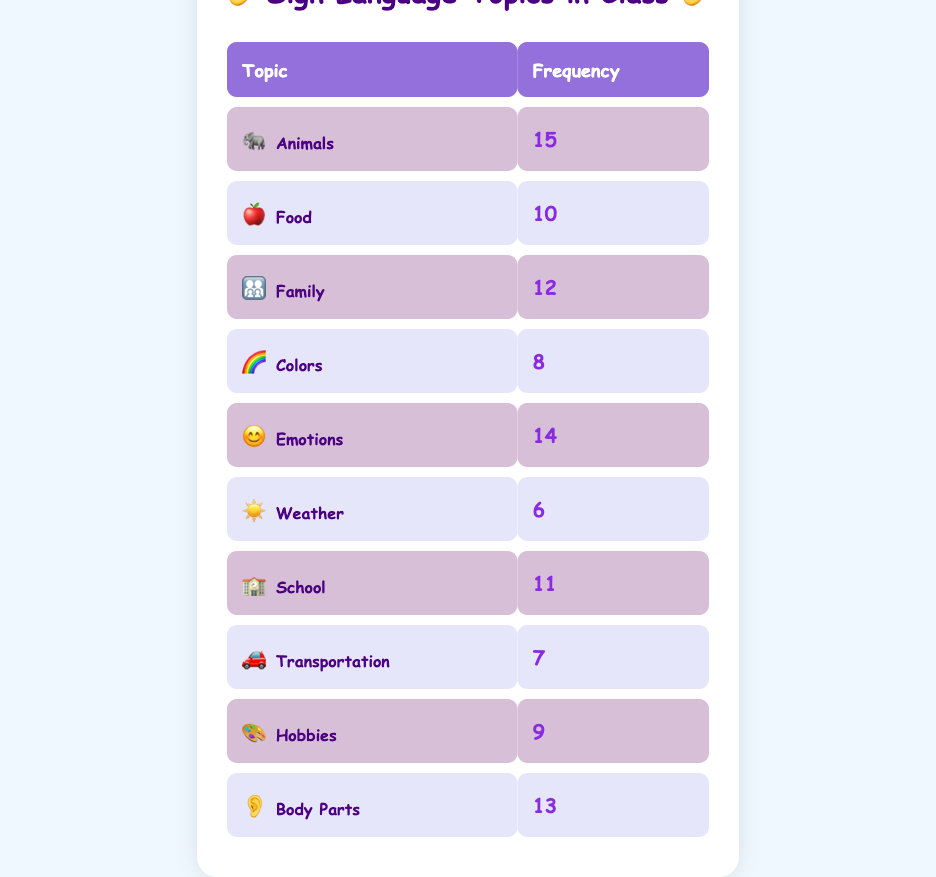What is the most frequently discussed sign language topic? The most frequently discussed topic in the table is "Animals," which has the highest frequency of 15.
Answer: Animals What is the frequency of the "Weather" topic? The table lists "Weather" with a frequency of 6.
Answer: 6 Which topic has a frequency higher than 12? The topics with frequencies higher than 12 are "Animals" (15), "Emotions" (14), and "Body Parts" (13).
Answer: Animals, Emotions, Body Parts What is the total frequency of all sign language topics discussed? Adding the frequencies: 15 (Animals) + 10 (Food) + 12 (Family) + 8 (Colors) + 14 (Emotions) + 6 (Weather) + 11 (School) + 7 (Transportation) + 9 (Hobbies) + 13 (Body Parts) =  15 + 10 + 12 + 8 + 14 + 6 + 11 + 7 + 9 + 13 =  15 + 10 = 25;  25 + 12 = 37;  37 + 8 = 45;  45 + 14 = 59;  59 + 6 = 65;  65 + 11 = 76;  76 + 7 = 83;  83 + 9 = 92;  92 + 13 = 105. The total frequency is 105.
Answer: 105 Is the frequency of "Colors" greater than the frequency of "Hobbies"? The frequency of "Colors" is 8, and the frequency of "Hobbies" is 9. Since 8 is not greater than 9, the answer is No.
Answer: No 